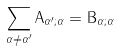<formula> <loc_0><loc_0><loc_500><loc_500>\sum _ { { \alpha } \not = { \alpha } ^ { \prime } } { \mathrm A } _ { \alpha ^ { \prime } ; \alpha } = { \mathrm B } _ { \alpha ; \alpha }</formula> 